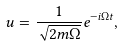<formula> <loc_0><loc_0><loc_500><loc_500>u = \frac { 1 } { \sqrt { 2 m \Omega } } e ^ { - i \Omega t } ,</formula> 